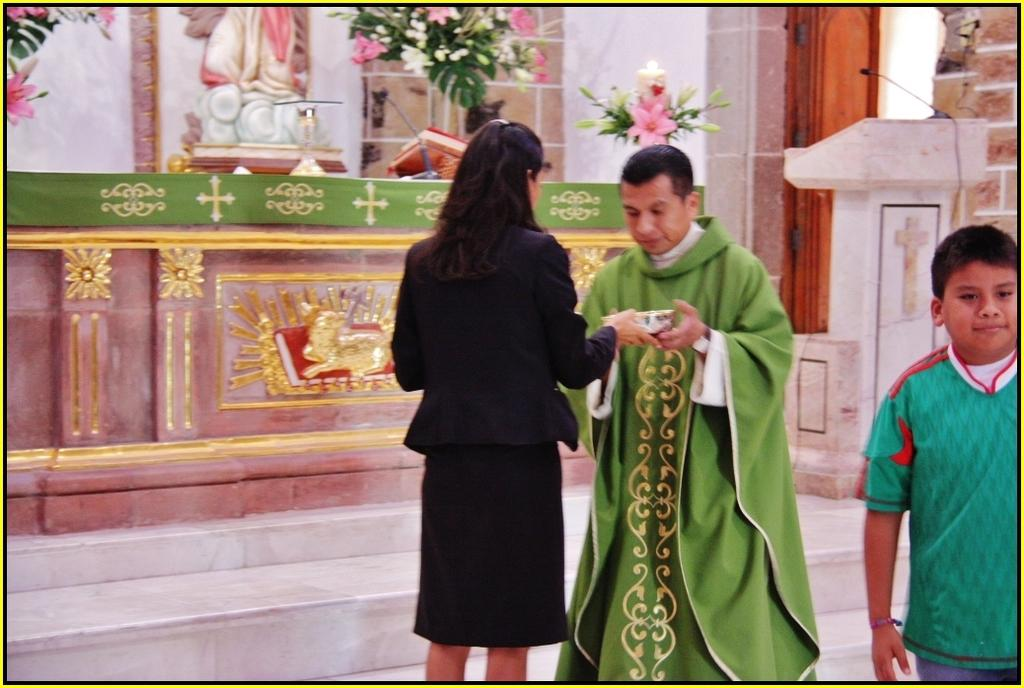What can be observed about the people in the image? There are people standing in the image. What is the woman holding in the image? A woman is holding a box in the image. What type of objects are visible in the image besides people? There are statues, flower pots, and a speaker stand with a mic in the image. What architectural feature can be seen in the image? There is a door in the image. What type of advice is being given by the stamp in the image? There is no stamp present in the image, so it is not possible to determine what advice might be given. 